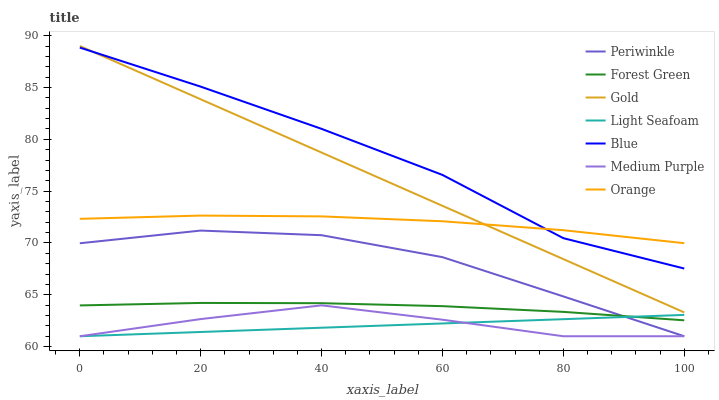Does Light Seafoam have the minimum area under the curve?
Answer yes or no. Yes. Does Blue have the maximum area under the curve?
Answer yes or no. Yes. Does Gold have the minimum area under the curve?
Answer yes or no. No. Does Gold have the maximum area under the curve?
Answer yes or no. No. Is Light Seafoam the smoothest?
Answer yes or no. Yes. Is Blue the roughest?
Answer yes or no. Yes. Is Gold the smoothest?
Answer yes or no. No. Is Gold the roughest?
Answer yes or no. No. Does Gold have the lowest value?
Answer yes or no. No. Does Gold have the highest value?
Answer yes or no. Yes. Does Medium Purple have the highest value?
Answer yes or no. No. Is Forest Green less than Blue?
Answer yes or no. Yes. Is Orange greater than Medium Purple?
Answer yes or no. Yes. Does Orange intersect Gold?
Answer yes or no. Yes. Is Orange less than Gold?
Answer yes or no. No. Is Orange greater than Gold?
Answer yes or no. No. Does Forest Green intersect Blue?
Answer yes or no. No. 